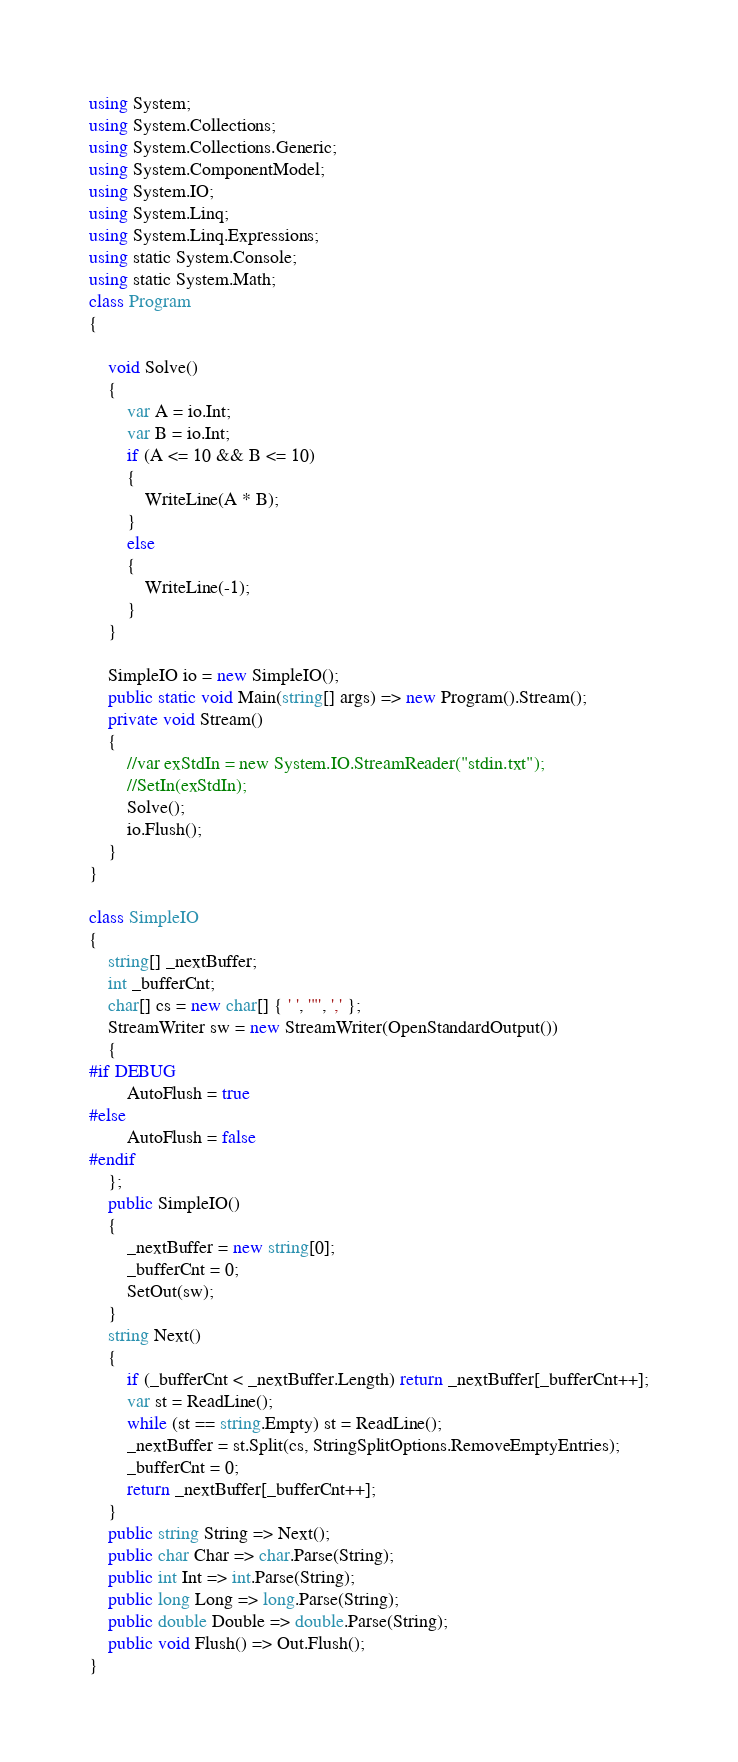Convert code to text. <code><loc_0><loc_0><loc_500><loc_500><_C#_>using System;
using System.Collections;
using System.Collections.Generic;
using System.ComponentModel;
using System.IO;
using System.Linq;
using System.Linq.Expressions;
using static System.Console;
using static System.Math;
class Program
{

    void Solve()
    {
        var A = io.Int;
        var B = io.Int;
        if (A <= 10 && B <= 10)
        {
            WriteLine(A * B);
        }
        else
        {
            WriteLine(-1);
        }
    }

    SimpleIO io = new SimpleIO();
    public static void Main(string[] args) => new Program().Stream();
    private void Stream()
    {
        //var exStdIn = new System.IO.StreamReader("stdin.txt");
        //SetIn(exStdIn);
        Solve();
        io.Flush();
    }
}

class SimpleIO
{
    string[] _nextBuffer;
    int _bufferCnt;
    char[] cs = new char[] { ' ', '"', ',' };
    StreamWriter sw = new StreamWriter(OpenStandardOutput())
    {
#if DEBUG
        AutoFlush = true
#else
        AutoFlush = false
#endif
    };
    public SimpleIO()
    {
        _nextBuffer = new string[0];
        _bufferCnt = 0;
        SetOut(sw);
    }
    string Next()
    {
        if (_bufferCnt < _nextBuffer.Length) return _nextBuffer[_bufferCnt++];
        var st = ReadLine();
        while (st == string.Empty) st = ReadLine();
        _nextBuffer = st.Split(cs, StringSplitOptions.RemoveEmptyEntries);
        _bufferCnt = 0;
        return _nextBuffer[_bufferCnt++];
    }
    public string String => Next();
    public char Char => char.Parse(String);
    public int Int => int.Parse(String);
    public long Long => long.Parse(String);
    public double Double => double.Parse(String);
    public void Flush() => Out.Flush();
}</code> 